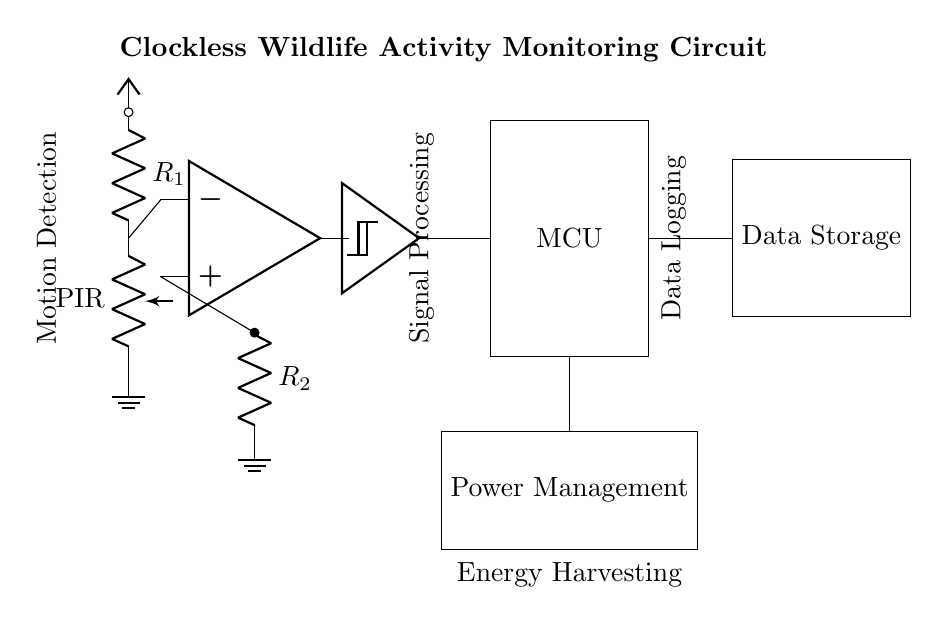What type of sensor is used in this circuit? The circuit includes a Passive Infrared (PIR) sensor for motion detection, indicated as "PIR" in the diagram.
Answer: PIR What component processes the signal after motion detection? The signal from the motion detection is processed by an operational amplifier (op amp) before it reaches the Schmitt trigger.
Answer: Op amp What is the function of the Schmitt trigger in this circuit? The Schmitt trigger is used for signal conditioning, providing a cleaner output signal from the varying input of the op amp to the microcontroller.
Answer: Signal conditioning How is the data stored in this circuit? Data is stored in the Data Storage component, which is connected directly to the microcontroller that processes the input signals.
Answer: Data Storage What additional feature does the circuit have for energy management? The circuit includes a Power Management component that is responsible for the efficient use and distribution of power, which is critical in a wildlife monitoring setup.
Answer: Power Management What role does the microcontroller play in this circuit? The microcontroller (MCU) interprets the processed signals from the Schmitt trigger and manages data storage and processing tasks.
Answer: Data processing How are the components of this circuit powered? The circuit is powered through a Vcc connection that supplies voltage to all components.
Answer: Vcc 